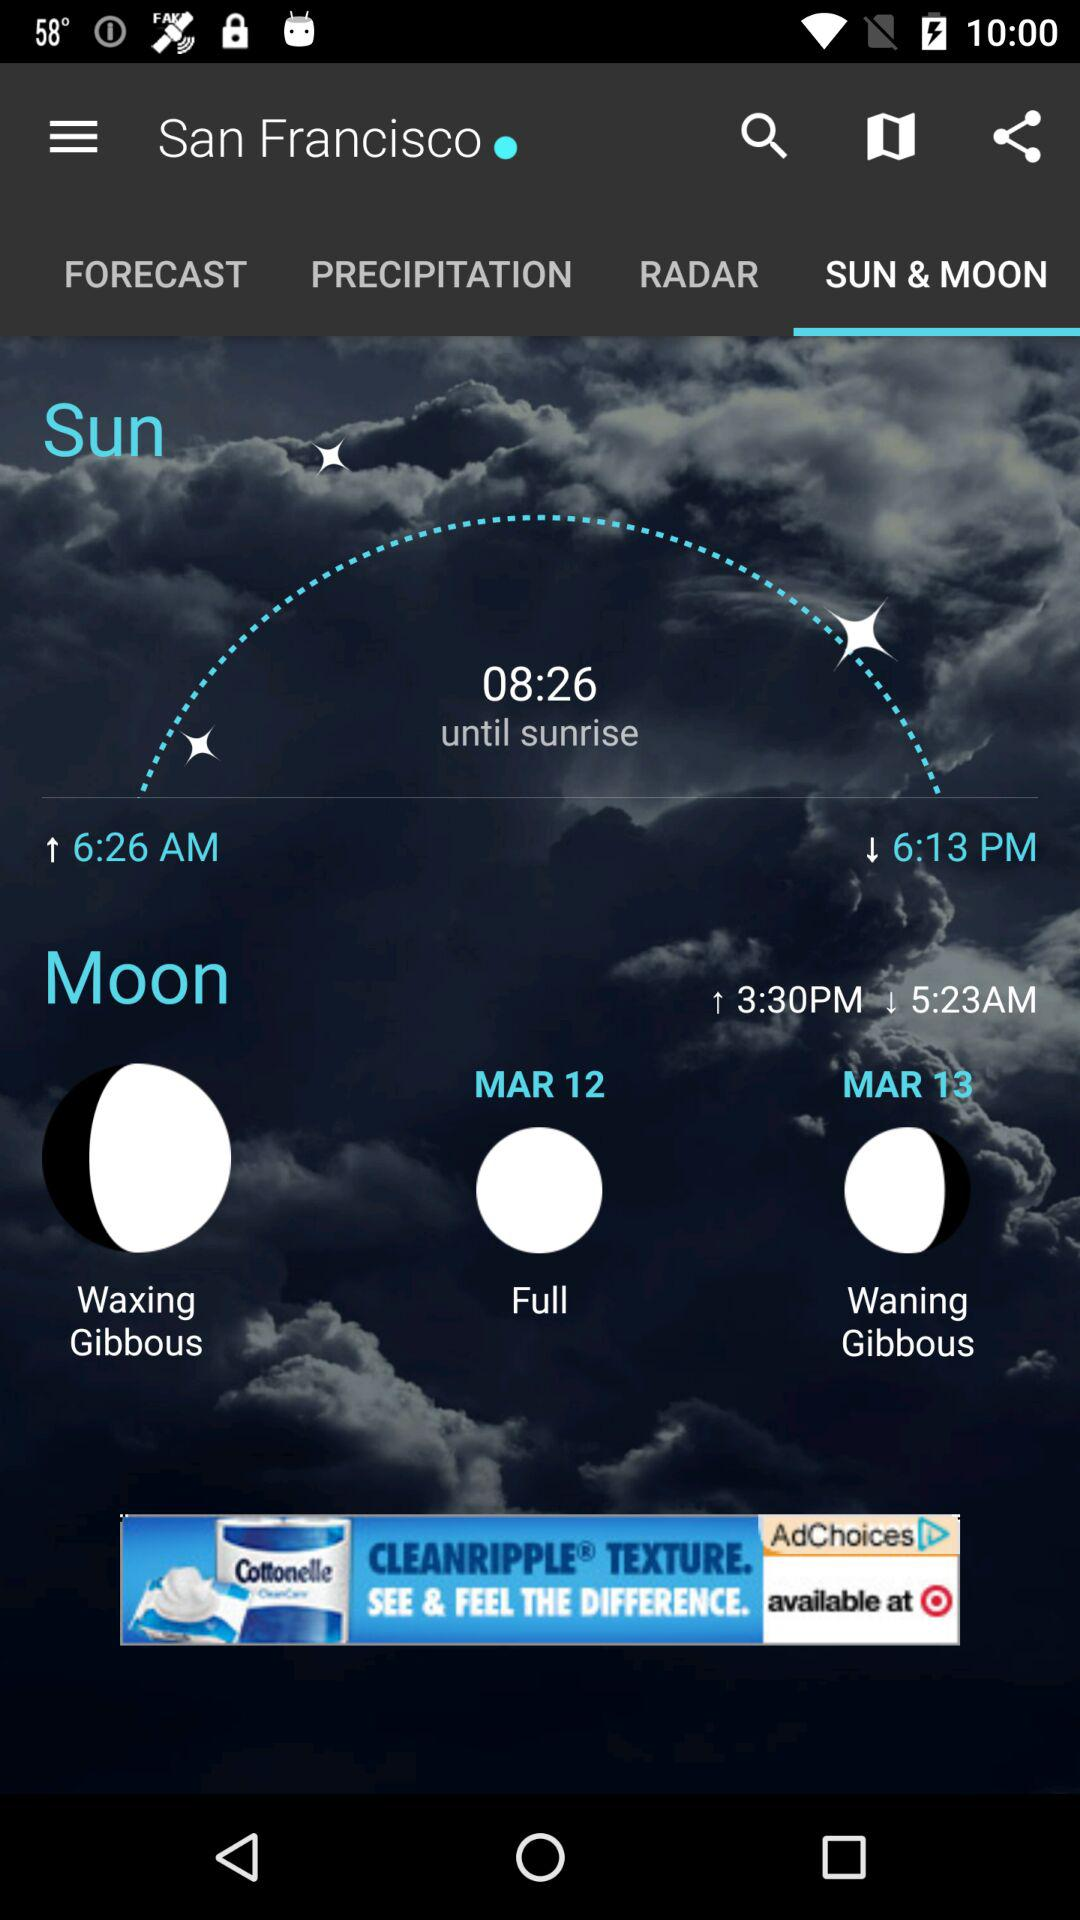What is the time range for the moon? The time range for the moon is from 3:30 PM to 5:23 AM. 